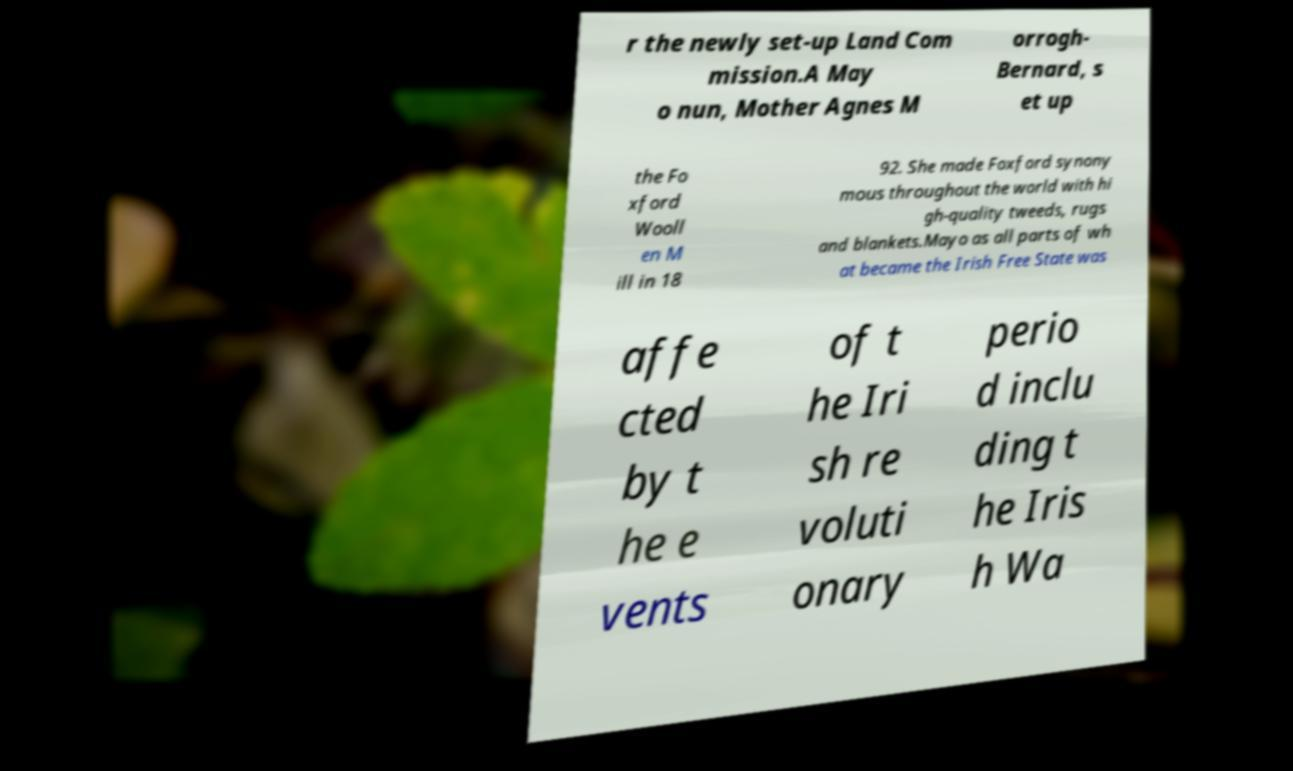Please identify and transcribe the text found in this image. r the newly set-up Land Com mission.A May o nun, Mother Agnes M orrogh- Bernard, s et up the Fo xford Wooll en M ill in 18 92. She made Foxford synony mous throughout the world with hi gh-quality tweeds, rugs and blankets.Mayo as all parts of wh at became the Irish Free State was affe cted by t he e vents of t he Iri sh re voluti onary perio d inclu ding t he Iris h Wa 